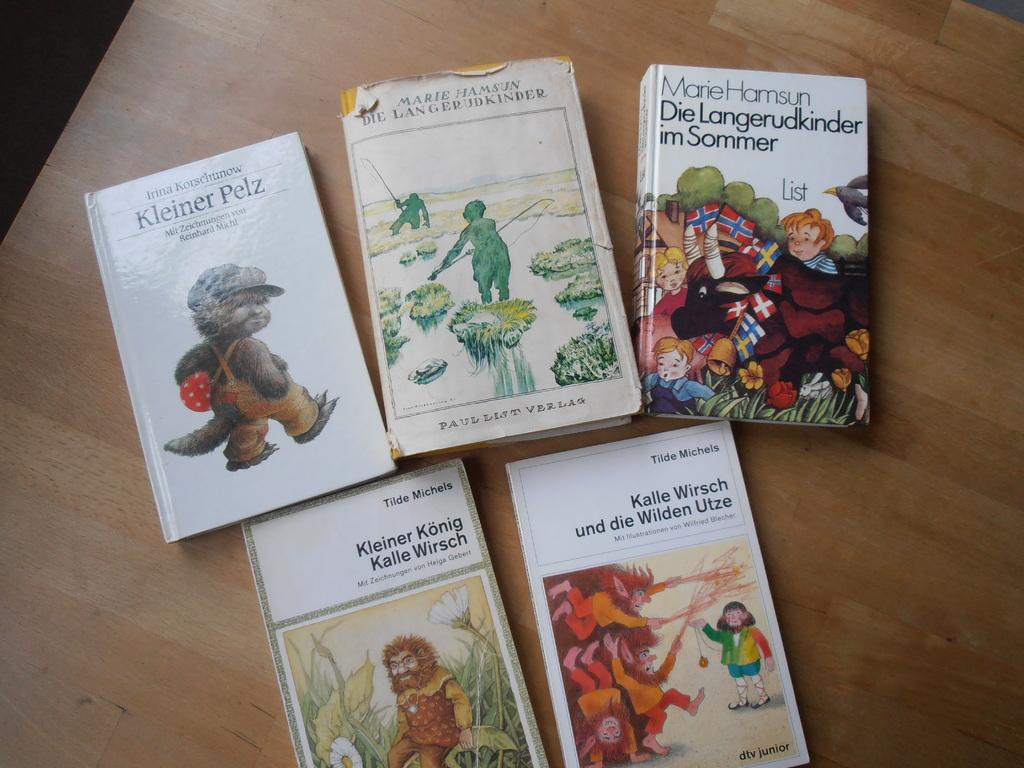Provide a one-sentence caption for the provided image. Five books sitting on a table, one with the title Kleiner Konig Kalle Wirsch. 